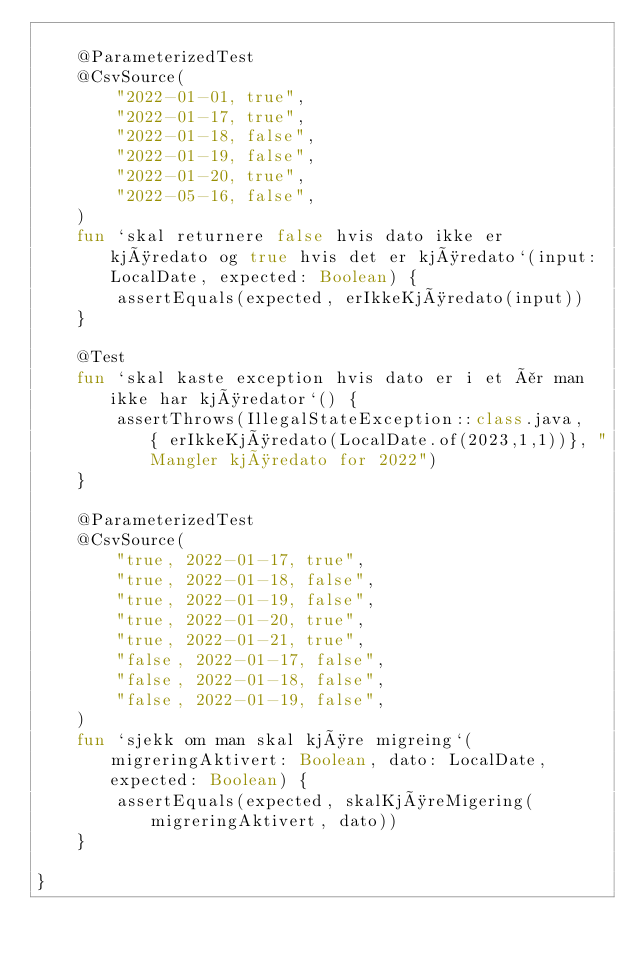<code> <loc_0><loc_0><loc_500><loc_500><_Kotlin_>
    @ParameterizedTest
    @CsvSource(
        "2022-01-01, true",
        "2022-01-17, true",
        "2022-01-18, false",
        "2022-01-19, false",
        "2022-01-20, true",
        "2022-05-16, false",
    )
    fun `skal returnere false hvis dato ikke er kjøredato og true hvis det er kjøredato`(input: LocalDate, expected: Boolean) {
        assertEquals(expected, erIkkeKjøredato(input))
    }

    @Test
    fun `skal kaste exception hvis dato er i et år man ikke har kjøredator`() {
        assertThrows(IllegalStateException::class.java,  { erIkkeKjøredato(LocalDate.of(2023,1,1))}, "Mangler kjøredato for 2022")
    }

    @ParameterizedTest
    @CsvSource(
        "true, 2022-01-17, true",
        "true, 2022-01-18, false",
        "true, 2022-01-19, false",
        "true, 2022-01-20, true",
        "true, 2022-01-21, true",
        "false, 2022-01-17, false",
        "false, 2022-01-18, false",
        "false, 2022-01-19, false",
    )
    fun `sjekk om man skal kjøre migreing`(migreringAktivert: Boolean, dato: LocalDate, expected: Boolean) {
        assertEquals(expected, skalKjøreMigering(migreringAktivert, dato))
    }

}</code> 